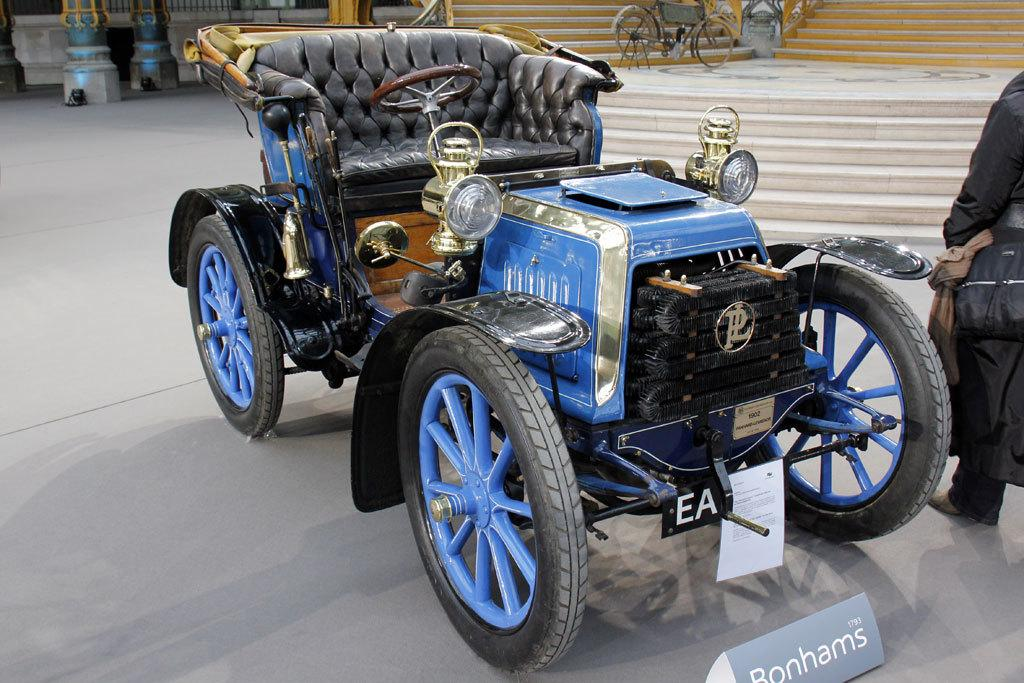What color is the vehicle in the image? The vehicle in the image is blue. Who or what is standing beside the vehicle? There is a person standing beside the vehicle. What else can be seen in the background of the image? There is a bicycle visible in the background of the image. What is the limit of the vehicle's speed in the image? The image does not provide information about the vehicle's speed or any limits. What is the person standing beside the vehicle doing with their mouth? The image does not show the person's mouth or any actions related to it. 